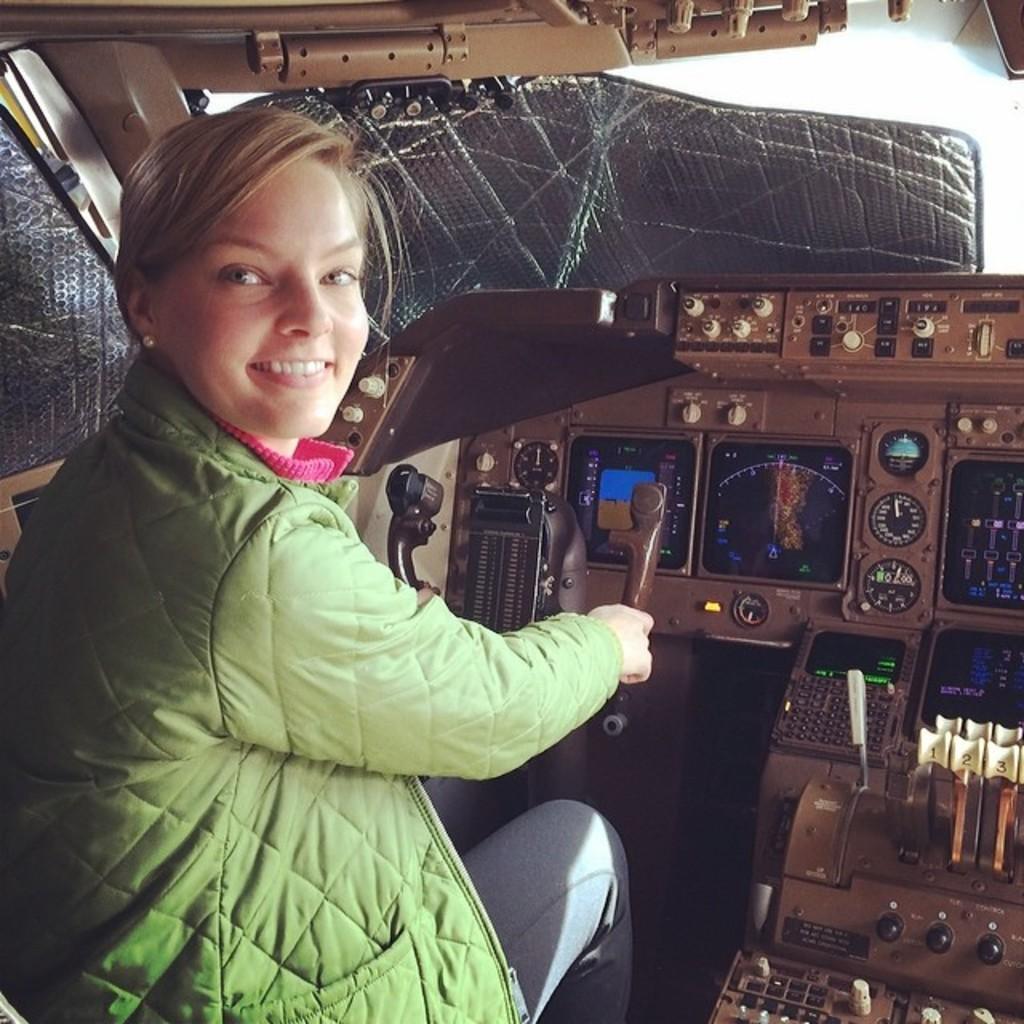Can you describe this image briefly? In this picture we can see a woman in the green jacket is sitting on a seat and smiling. In front of the women there are some items. 